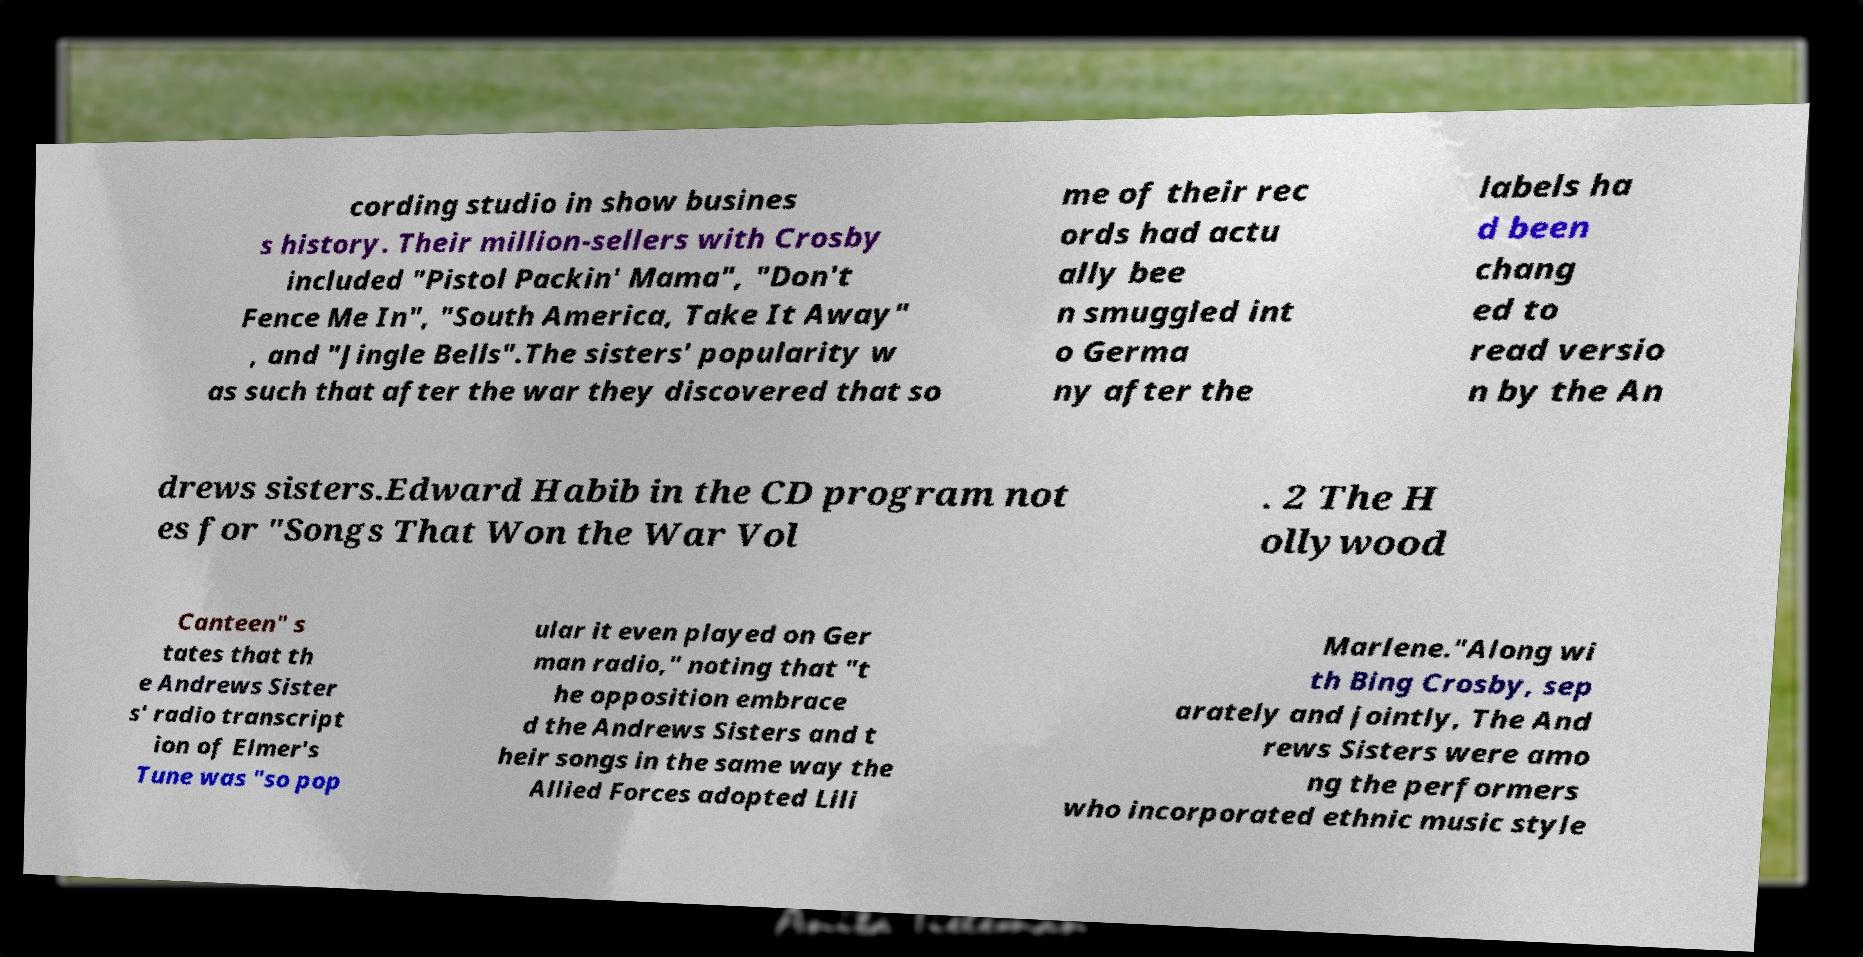Can you accurately transcribe the text from the provided image for me? cording studio in show busines s history. Their million-sellers with Crosby included "Pistol Packin' Mama", "Don't Fence Me In", "South America, Take It Away" , and "Jingle Bells".The sisters' popularity w as such that after the war they discovered that so me of their rec ords had actu ally bee n smuggled int o Germa ny after the labels ha d been chang ed to read versio n by the An drews sisters.Edward Habib in the CD program not es for "Songs That Won the War Vol . 2 The H ollywood Canteen" s tates that th e Andrews Sister s' radio transcript ion of Elmer's Tune was "so pop ular it even played on Ger man radio," noting that "t he opposition embrace d the Andrews Sisters and t heir songs in the same way the Allied Forces adopted Lili Marlene."Along wi th Bing Crosby, sep arately and jointly, The And rews Sisters were amo ng the performers who incorporated ethnic music style 